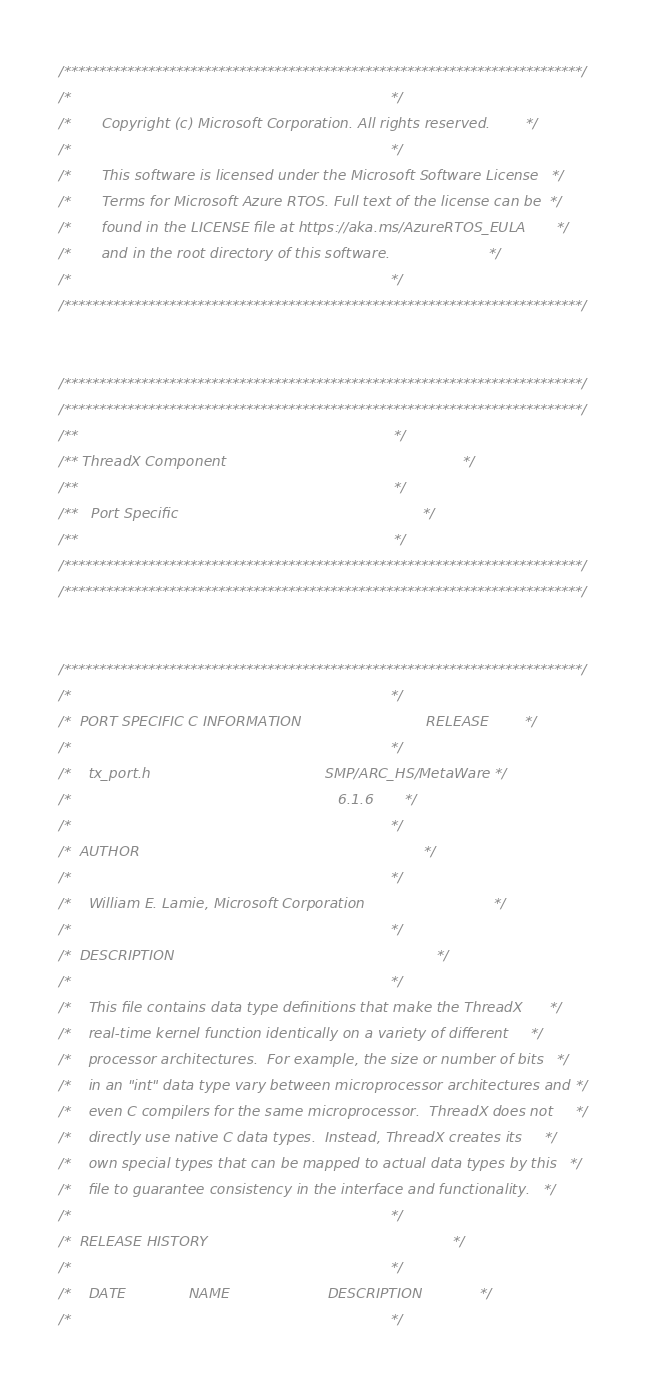Convert code to text. <code><loc_0><loc_0><loc_500><loc_500><_C_>/**************************************************************************/
/*                                                                        */
/*       Copyright (c) Microsoft Corporation. All rights reserved.        */
/*                                                                        */
/*       This software is licensed under the Microsoft Software License   */
/*       Terms for Microsoft Azure RTOS. Full text of the license can be  */
/*       found in the LICENSE file at https://aka.ms/AzureRTOS_EULA       */
/*       and in the root directory of this software.                      */
/*                                                                        */
/**************************************************************************/


/**************************************************************************/
/**************************************************************************/
/**                                                                       */ 
/** ThreadX Component                                                     */
/**                                                                       */
/**   Port Specific                                                       */
/**                                                                       */
/**************************************************************************/
/**************************************************************************/


/**************************************************************************/ 
/*                                                                        */ 
/*  PORT SPECIFIC C INFORMATION                            RELEASE        */ 
/*                                                                        */ 
/*    tx_port.h                                       SMP/ARC_HS/MetaWare */ 
/*                                                            6.1.6       */
/*                                                                        */
/*  AUTHOR                                                                */
/*                                                                        */
/*    William E. Lamie, Microsoft Corporation                             */
/*                                                                        */
/*  DESCRIPTION                                                           */
/*                                                                        */ 
/*    This file contains data type definitions that make the ThreadX      */ 
/*    real-time kernel function identically on a variety of different     */ 
/*    processor architectures.  For example, the size or number of bits   */ 
/*    in an "int" data type vary between microprocessor architectures and */ 
/*    even C compilers for the same microprocessor.  ThreadX does not     */ 
/*    directly use native C data types.  Instead, ThreadX creates its     */ 
/*    own special types that can be mapped to actual data types by this   */ 
/*    file to guarantee consistency in the interface and functionality.   */ 
/*                                                                        */ 
/*  RELEASE HISTORY                                                       */ 
/*                                                                        */ 
/*    DATE              NAME                      DESCRIPTION             */
/*                                                                        */</code> 